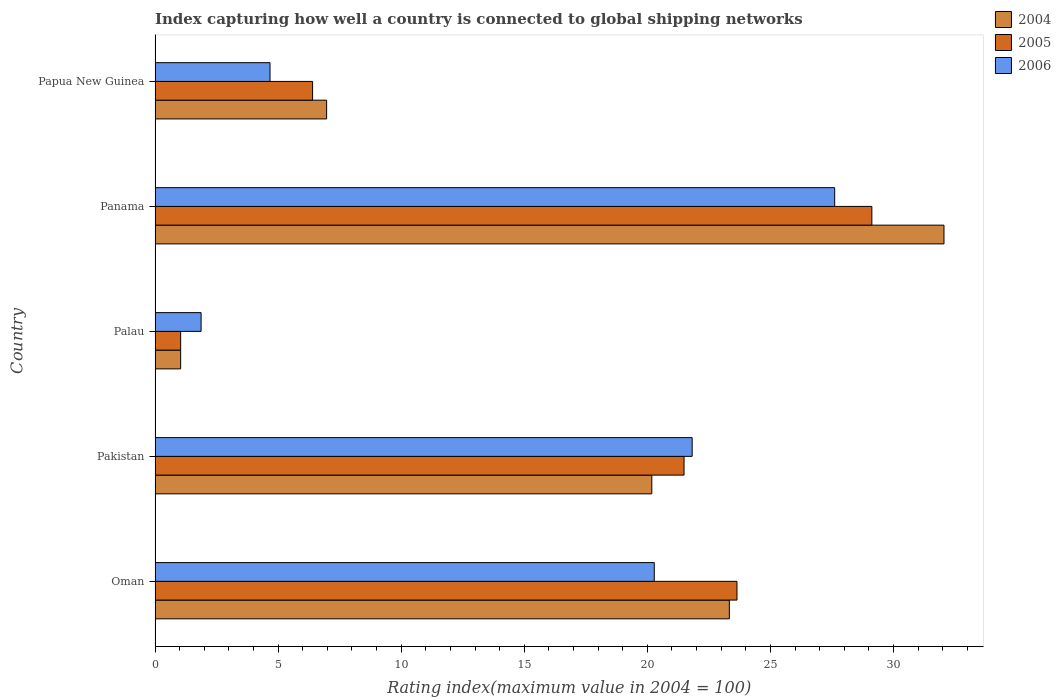Are the number of bars on each tick of the Y-axis equal?
Provide a succinct answer. Yes. How many bars are there on the 2nd tick from the top?
Ensure brevity in your answer.  3. What is the label of the 1st group of bars from the top?
Your answer should be very brief. Papua New Guinea. What is the rating index in 2006 in Papua New Guinea?
Provide a succinct answer. 4.67. Across all countries, what is the maximum rating index in 2006?
Your answer should be very brief. 27.61. Across all countries, what is the minimum rating index in 2006?
Provide a short and direct response. 1.87. In which country was the rating index in 2006 maximum?
Make the answer very short. Panama. In which country was the rating index in 2005 minimum?
Keep it short and to the point. Palau. What is the total rating index in 2004 in the graph?
Your answer should be very brief. 83.57. What is the difference between the rating index in 2004 in Palau and that in Papua New Guinea?
Your answer should be very brief. -5.93. What is the difference between the rating index in 2004 in Panama and the rating index in 2006 in Palau?
Give a very brief answer. 30.18. What is the average rating index in 2006 per country?
Give a very brief answer. 15.25. What is the difference between the rating index in 2004 and rating index in 2006 in Papua New Guinea?
Your response must be concise. 2.3. What is the ratio of the rating index in 2006 in Palau to that in Papua New Guinea?
Offer a very short reply. 0.4. What is the difference between the highest and the second highest rating index in 2006?
Offer a very short reply. 5.79. What is the difference between the highest and the lowest rating index in 2004?
Keep it short and to the point. 31.01. What does the 2nd bar from the bottom in Papua New Guinea represents?
Your answer should be compact. 2005. Is it the case that in every country, the sum of the rating index in 2004 and rating index in 2005 is greater than the rating index in 2006?
Offer a very short reply. Yes. How many bars are there?
Make the answer very short. 15. What is the difference between two consecutive major ticks on the X-axis?
Provide a succinct answer. 5. Does the graph contain any zero values?
Your response must be concise. No. Where does the legend appear in the graph?
Keep it short and to the point. Top right. What is the title of the graph?
Give a very brief answer. Index capturing how well a country is connected to global shipping networks. What is the label or title of the X-axis?
Provide a short and direct response. Rating index(maximum value in 2004 = 100). What is the Rating index(maximum value in 2004 = 100) of 2004 in Oman?
Your answer should be compact. 23.33. What is the Rating index(maximum value in 2004 = 100) of 2005 in Oman?
Your answer should be very brief. 23.64. What is the Rating index(maximum value in 2004 = 100) in 2006 in Oman?
Provide a succinct answer. 20.28. What is the Rating index(maximum value in 2004 = 100) of 2004 in Pakistan?
Keep it short and to the point. 20.18. What is the Rating index(maximum value in 2004 = 100) in 2005 in Pakistan?
Your answer should be very brief. 21.49. What is the Rating index(maximum value in 2004 = 100) of 2006 in Pakistan?
Offer a very short reply. 21.82. What is the Rating index(maximum value in 2004 = 100) in 2004 in Palau?
Offer a very short reply. 1.04. What is the Rating index(maximum value in 2004 = 100) in 2006 in Palau?
Provide a succinct answer. 1.87. What is the Rating index(maximum value in 2004 = 100) of 2004 in Panama?
Ensure brevity in your answer.  32.05. What is the Rating index(maximum value in 2004 = 100) in 2005 in Panama?
Make the answer very short. 29.12. What is the Rating index(maximum value in 2004 = 100) in 2006 in Panama?
Your answer should be very brief. 27.61. What is the Rating index(maximum value in 2004 = 100) in 2004 in Papua New Guinea?
Your answer should be compact. 6.97. What is the Rating index(maximum value in 2004 = 100) in 2005 in Papua New Guinea?
Your response must be concise. 6.4. What is the Rating index(maximum value in 2004 = 100) of 2006 in Papua New Guinea?
Your answer should be compact. 4.67. Across all countries, what is the maximum Rating index(maximum value in 2004 = 100) in 2004?
Provide a succinct answer. 32.05. Across all countries, what is the maximum Rating index(maximum value in 2004 = 100) of 2005?
Make the answer very short. 29.12. Across all countries, what is the maximum Rating index(maximum value in 2004 = 100) of 2006?
Make the answer very short. 27.61. Across all countries, what is the minimum Rating index(maximum value in 2004 = 100) in 2005?
Give a very brief answer. 1.04. Across all countries, what is the minimum Rating index(maximum value in 2004 = 100) of 2006?
Your answer should be compact. 1.87. What is the total Rating index(maximum value in 2004 = 100) of 2004 in the graph?
Your answer should be compact. 83.57. What is the total Rating index(maximum value in 2004 = 100) of 2005 in the graph?
Keep it short and to the point. 81.69. What is the total Rating index(maximum value in 2004 = 100) in 2006 in the graph?
Your response must be concise. 76.25. What is the difference between the Rating index(maximum value in 2004 = 100) in 2004 in Oman and that in Pakistan?
Keep it short and to the point. 3.15. What is the difference between the Rating index(maximum value in 2004 = 100) of 2005 in Oman and that in Pakistan?
Offer a terse response. 2.15. What is the difference between the Rating index(maximum value in 2004 = 100) in 2006 in Oman and that in Pakistan?
Ensure brevity in your answer.  -1.54. What is the difference between the Rating index(maximum value in 2004 = 100) in 2004 in Oman and that in Palau?
Your response must be concise. 22.29. What is the difference between the Rating index(maximum value in 2004 = 100) in 2005 in Oman and that in Palau?
Ensure brevity in your answer.  22.6. What is the difference between the Rating index(maximum value in 2004 = 100) of 2006 in Oman and that in Palau?
Your answer should be very brief. 18.41. What is the difference between the Rating index(maximum value in 2004 = 100) of 2004 in Oman and that in Panama?
Keep it short and to the point. -8.72. What is the difference between the Rating index(maximum value in 2004 = 100) of 2005 in Oman and that in Panama?
Provide a succinct answer. -5.48. What is the difference between the Rating index(maximum value in 2004 = 100) in 2006 in Oman and that in Panama?
Give a very brief answer. -7.33. What is the difference between the Rating index(maximum value in 2004 = 100) in 2004 in Oman and that in Papua New Guinea?
Ensure brevity in your answer.  16.36. What is the difference between the Rating index(maximum value in 2004 = 100) of 2005 in Oman and that in Papua New Guinea?
Ensure brevity in your answer.  17.24. What is the difference between the Rating index(maximum value in 2004 = 100) of 2006 in Oman and that in Papua New Guinea?
Offer a very short reply. 15.61. What is the difference between the Rating index(maximum value in 2004 = 100) of 2004 in Pakistan and that in Palau?
Make the answer very short. 19.14. What is the difference between the Rating index(maximum value in 2004 = 100) of 2005 in Pakistan and that in Palau?
Offer a terse response. 20.45. What is the difference between the Rating index(maximum value in 2004 = 100) in 2006 in Pakistan and that in Palau?
Give a very brief answer. 19.95. What is the difference between the Rating index(maximum value in 2004 = 100) of 2004 in Pakistan and that in Panama?
Provide a succinct answer. -11.87. What is the difference between the Rating index(maximum value in 2004 = 100) of 2005 in Pakistan and that in Panama?
Give a very brief answer. -7.63. What is the difference between the Rating index(maximum value in 2004 = 100) of 2006 in Pakistan and that in Panama?
Provide a short and direct response. -5.79. What is the difference between the Rating index(maximum value in 2004 = 100) in 2004 in Pakistan and that in Papua New Guinea?
Your response must be concise. 13.21. What is the difference between the Rating index(maximum value in 2004 = 100) of 2005 in Pakistan and that in Papua New Guinea?
Your response must be concise. 15.09. What is the difference between the Rating index(maximum value in 2004 = 100) of 2006 in Pakistan and that in Papua New Guinea?
Provide a succinct answer. 17.15. What is the difference between the Rating index(maximum value in 2004 = 100) in 2004 in Palau and that in Panama?
Make the answer very short. -31.01. What is the difference between the Rating index(maximum value in 2004 = 100) of 2005 in Palau and that in Panama?
Offer a very short reply. -28.08. What is the difference between the Rating index(maximum value in 2004 = 100) of 2006 in Palau and that in Panama?
Keep it short and to the point. -25.74. What is the difference between the Rating index(maximum value in 2004 = 100) of 2004 in Palau and that in Papua New Guinea?
Offer a very short reply. -5.93. What is the difference between the Rating index(maximum value in 2004 = 100) in 2005 in Palau and that in Papua New Guinea?
Give a very brief answer. -5.36. What is the difference between the Rating index(maximum value in 2004 = 100) in 2004 in Panama and that in Papua New Guinea?
Your answer should be compact. 25.08. What is the difference between the Rating index(maximum value in 2004 = 100) in 2005 in Panama and that in Papua New Guinea?
Offer a terse response. 22.72. What is the difference between the Rating index(maximum value in 2004 = 100) of 2006 in Panama and that in Papua New Guinea?
Provide a short and direct response. 22.94. What is the difference between the Rating index(maximum value in 2004 = 100) in 2004 in Oman and the Rating index(maximum value in 2004 = 100) in 2005 in Pakistan?
Make the answer very short. 1.84. What is the difference between the Rating index(maximum value in 2004 = 100) of 2004 in Oman and the Rating index(maximum value in 2004 = 100) of 2006 in Pakistan?
Offer a very short reply. 1.51. What is the difference between the Rating index(maximum value in 2004 = 100) in 2005 in Oman and the Rating index(maximum value in 2004 = 100) in 2006 in Pakistan?
Keep it short and to the point. 1.82. What is the difference between the Rating index(maximum value in 2004 = 100) of 2004 in Oman and the Rating index(maximum value in 2004 = 100) of 2005 in Palau?
Keep it short and to the point. 22.29. What is the difference between the Rating index(maximum value in 2004 = 100) of 2004 in Oman and the Rating index(maximum value in 2004 = 100) of 2006 in Palau?
Offer a very short reply. 21.46. What is the difference between the Rating index(maximum value in 2004 = 100) of 2005 in Oman and the Rating index(maximum value in 2004 = 100) of 2006 in Palau?
Keep it short and to the point. 21.77. What is the difference between the Rating index(maximum value in 2004 = 100) in 2004 in Oman and the Rating index(maximum value in 2004 = 100) in 2005 in Panama?
Your answer should be compact. -5.79. What is the difference between the Rating index(maximum value in 2004 = 100) of 2004 in Oman and the Rating index(maximum value in 2004 = 100) of 2006 in Panama?
Offer a terse response. -4.28. What is the difference between the Rating index(maximum value in 2004 = 100) in 2005 in Oman and the Rating index(maximum value in 2004 = 100) in 2006 in Panama?
Provide a short and direct response. -3.97. What is the difference between the Rating index(maximum value in 2004 = 100) of 2004 in Oman and the Rating index(maximum value in 2004 = 100) of 2005 in Papua New Guinea?
Ensure brevity in your answer.  16.93. What is the difference between the Rating index(maximum value in 2004 = 100) of 2004 in Oman and the Rating index(maximum value in 2004 = 100) of 2006 in Papua New Guinea?
Provide a short and direct response. 18.66. What is the difference between the Rating index(maximum value in 2004 = 100) of 2005 in Oman and the Rating index(maximum value in 2004 = 100) of 2006 in Papua New Guinea?
Give a very brief answer. 18.97. What is the difference between the Rating index(maximum value in 2004 = 100) in 2004 in Pakistan and the Rating index(maximum value in 2004 = 100) in 2005 in Palau?
Provide a short and direct response. 19.14. What is the difference between the Rating index(maximum value in 2004 = 100) in 2004 in Pakistan and the Rating index(maximum value in 2004 = 100) in 2006 in Palau?
Give a very brief answer. 18.31. What is the difference between the Rating index(maximum value in 2004 = 100) in 2005 in Pakistan and the Rating index(maximum value in 2004 = 100) in 2006 in Palau?
Your answer should be compact. 19.62. What is the difference between the Rating index(maximum value in 2004 = 100) in 2004 in Pakistan and the Rating index(maximum value in 2004 = 100) in 2005 in Panama?
Make the answer very short. -8.94. What is the difference between the Rating index(maximum value in 2004 = 100) in 2004 in Pakistan and the Rating index(maximum value in 2004 = 100) in 2006 in Panama?
Provide a short and direct response. -7.43. What is the difference between the Rating index(maximum value in 2004 = 100) in 2005 in Pakistan and the Rating index(maximum value in 2004 = 100) in 2006 in Panama?
Make the answer very short. -6.12. What is the difference between the Rating index(maximum value in 2004 = 100) of 2004 in Pakistan and the Rating index(maximum value in 2004 = 100) of 2005 in Papua New Guinea?
Offer a terse response. 13.78. What is the difference between the Rating index(maximum value in 2004 = 100) in 2004 in Pakistan and the Rating index(maximum value in 2004 = 100) in 2006 in Papua New Guinea?
Provide a succinct answer. 15.51. What is the difference between the Rating index(maximum value in 2004 = 100) in 2005 in Pakistan and the Rating index(maximum value in 2004 = 100) in 2006 in Papua New Guinea?
Your answer should be very brief. 16.82. What is the difference between the Rating index(maximum value in 2004 = 100) in 2004 in Palau and the Rating index(maximum value in 2004 = 100) in 2005 in Panama?
Keep it short and to the point. -28.08. What is the difference between the Rating index(maximum value in 2004 = 100) in 2004 in Palau and the Rating index(maximum value in 2004 = 100) in 2006 in Panama?
Your answer should be compact. -26.57. What is the difference between the Rating index(maximum value in 2004 = 100) of 2005 in Palau and the Rating index(maximum value in 2004 = 100) of 2006 in Panama?
Keep it short and to the point. -26.57. What is the difference between the Rating index(maximum value in 2004 = 100) of 2004 in Palau and the Rating index(maximum value in 2004 = 100) of 2005 in Papua New Guinea?
Your answer should be compact. -5.36. What is the difference between the Rating index(maximum value in 2004 = 100) of 2004 in Palau and the Rating index(maximum value in 2004 = 100) of 2006 in Papua New Guinea?
Ensure brevity in your answer.  -3.63. What is the difference between the Rating index(maximum value in 2004 = 100) in 2005 in Palau and the Rating index(maximum value in 2004 = 100) in 2006 in Papua New Guinea?
Your answer should be compact. -3.63. What is the difference between the Rating index(maximum value in 2004 = 100) in 2004 in Panama and the Rating index(maximum value in 2004 = 100) in 2005 in Papua New Guinea?
Your answer should be very brief. 25.65. What is the difference between the Rating index(maximum value in 2004 = 100) in 2004 in Panama and the Rating index(maximum value in 2004 = 100) in 2006 in Papua New Guinea?
Offer a terse response. 27.38. What is the difference between the Rating index(maximum value in 2004 = 100) in 2005 in Panama and the Rating index(maximum value in 2004 = 100) in 2006 in Papua New Guinea?
Ensure brevity in your answer.  24.45. What is the average Rating index(maximum value in 2004 = 100) in 2004 per country?
Keep it short and to the point. 16.71. What is the average Rating index(maximum value in 2004 = 100) in 2005 per country?
Offer a very short reply. 16.34. What is the average Rating index(maximum value in 2004 = 100) in 2006 per country?
Make the answer very short. 15.25. What is the difference between the Rating index(maximum value in 2004 = 100) of 2004 and Rating index(maximum value in 2004 = 100) of 2005 in Oman?
Offer a terse response. -0.31. What is the difference between the Rating index(maximum value in 2004 = 100) of 2004 and Rating index(maximum value in 2004 = 100) of 2006 in Oman?
Your answer should be very brief. 3.05. What is the difference between the Rating index(maximum value in 2004 = 100) of 2005 and Rating index(maximum value in 2004 = 100) of 2006 in Oman?
Provide a short and direct response. 3.36. What is the difference between the Rating index(maximum value in 2004 = 100) of 2004 and Rating index(maximum value in 2004 = 100) of 2005 in Pakistan?
Offer a terse response. -1.31. What is the difference between the Rating index(maximum value in 2004 = 100) of 2004 and Rating index(maximum value in 2004 = 100) of 2006 in Pakistan?
Your answer should be very brief. -1.64. What is the difference between the Rating index(maximum value in 2004 = 100) in 2005 and Rating index(maximum value in 2004 = 100) in 2006 in Pakistan?
Your answer should be very brief. -0.33. What is the difference between the Rating index(maximum value in 2004 = 100) of 2004 and Rating index(maximum value in 2004 = 100) of 2006 in Palau?
Offer a terse response. -0.83. What is the difference between the Rating index(maximum value in 2004 = 100) in 2005 and Rating index(maximum value in 2004 = 100) in 2006 in Palau?
Provide a short and direct response. -0.83. What is the difference between the Rating index(maximum value in 2004 = 100) in 2004 and Rating index(maximum value in 2004 = 100) in 2005 in Panama?
Your answer should be compact. 2.93. What is the difference between the Rating index(maximum value in 2004 = 100) in 2004 and Rating index(maximum value in 2004 = 100) in 2006 in Panama?
Your answer should be compact. 4.44. What is the difference between the Rating index(maximum value in 2004 = 100) in 2005 and Rating index(maximum value in 2004 = 100) in 2006 in Panama?
Your answer should be compact. 1.51. What is the difference between the Rating index(maximum value in 2004 = 100) of 2004 and Rating index(maximum value in 2004 = 100) of 2005 in Papua New Guinea?
Give a very brief answer. 0.57. What is the difference between the Rating index(maximum value in 2004 = 100) in 2004 and Rating index(maximum value in 2004 = 100) in 2006 in Papua New Guinea?
Provide a short and direct response. 2.3. What is the difference between the Rating index(maximum value in 2004 = 100) of 2005 and Rating index(maximum value in 2004 = 100) of 2006 in Papua New Guinea?
Ensure brevity in your answer.  1.73. What is the ratio of the Rating index(maximum value in 2004 = 100) of 2004 in Oman to that in Pakistan?
Make the answer very short. 1.16. What is the ratio of the Rating index(maximum value in 2004 = 100) of 2005 in Oman to that in Pakistan?
Offer a very short reply. 1.1. What is the ratio of the Rating index(maximum value in 2004 = 100) in 2006 in Oman to that in Pakistan?
Offer a terse response. 0.93. What is the ratio of the Rating index(maximum value in 2004 = 100) of 2004 in Oman to that in Palau?
Ensure brevity in your answer.  22.43. What is the ratio of the Rating index(maximum value in 2004 = 100) in 2005 in Oman to that in Palau?
Your answer should be very brief. 22.73. What is the ratio of the Rating index(maximum value in 2004 = 100) in 2006 in Oman to that in Palau?
Offer a terse response. 10.84. What is the ratio of the Rating index(maximum value in 2004 = 100) of 2004 in Oman to that in Panama?
Offer a terse response. 0.73. What is the ratio of the Rating index(maximum value in 2004 = 100) in 2005 in Oman to that in Panama?
Your answer should be compact. 0.81. What is the ratio of the Rating index(maximum value in 2004 = 100) of 2006 in Oman to that in Panama?
Offer a very short reply. 0.73. What is the ratio of the Rating index(maximum value in 2004 = 100) in 2004 in Oman to that in Papua New Guinea?
Ensure brevity in your answer.  3.35. What is the ratio of the Rating index(maximum value in 2004 = 100) in 2005 in Oman to that in Papua New Guinea?
Make the answer very short. 3.69. What is the ratio of the Rating index(maximum value in 2004 = 100) of 2006 in Oman to that in Papua New Guinea?
Provide a short and direct response. 4.34. What is the ratio of the Rating index(maximum value in 2004 = 100) in 2004 in Pakistan to that in Palau?
Your response must be concise. 19.4. What is the ratio of the Rating index(maximum value in 2004 = 100) in 2005 in Pakistan to that in Palau?
Offer a terse response. 20.66. What is the ratio of the Rating index(maximum value in 2004 = 100) in 2006 in Pakistan to that in Palau?
Provide a short and direct response. 11.67. What is the ratio of the Rating index(maximum value in 2004 = 100) of 2004 in Pakistan to that in Panama?
Ensure brevity in your answer.  0.63. What is the ratio of the Rating index(maximum value in 2004 = 100) of 2005 in Pakistan to that in Panama?
Give a very brief answer. 0.74. What is the ratio of the Rating index(maximum value in 2004 = 100) in 2006 in Pakistan to that in Panama?
Keep it short and to the point. 0.79. What is the ratio of the Rating index(maximum value in 2004 = 100) in 2004 in Pakistan to that in Papua New Guinea?
Your answer should be very brief. 2.9. What is the ratio of the Rating index(maximum value in 2004 = 100) of 2005 in Pakistan to that in Papua New Guinea?
Your response must be concise. 3.36. What is the ratio of the Rating index(maximum value in 2004 = 100) of 2006 in Pakistan to that in Papua New Guinea?
Ensure brevity in your answer.  4.67. What is the ratio of the Rating index(maximum value in 2004 = 100) of 2004 in Palau to that in Panama?
Your answer should be very brief. 0.03. What is the ratio of the Rating index(maximum value in 2004 = 100) of 2005 in Palau to that in Panama?
Your answer should be very brief. 0.04. What is the ratio of the Rating index(maximum value in 2004 = 100) of 2006 in Palau to that in Panama?
Make the answer very short. 0.07. What is the ratio of the Rating index(maximum value in 2004 = 100) in 2004 in Palau to that in Papua New Guinea?
Offer a terse response. 0.15. What is the ratio of the Rating index(maximum value in 2004 = 100) in 2005 in Palau to that in Papua New Guinea?
Your response must be concise. 0.16. What is the ratio of the Rating index(maximum value in 2004 = 100) of 2006 in Palau to that in Papua New Guinea?
Provide a short and direct response. 0.4. What is the ratio of the Rating index(maximum value in 2004 = 100) of 2004 in Panama to that in Papua New Guinea?
Offer a very short reply. 4.6. What is the ratio of the Rating index(maximum value in 2004 = 100) of 2005 in Panama to that in Papua New Guinea?
Your answer should be compact. 4.55. What is the ratio of the Rating index(maximum value in 2004 = 100) in 2006 in Panama to that in Papua New Guinea?
Your answer should be very brief. 5.91. What is the difference between the highest and the second highest Rating index(maximum value in 2004 = 100) of 2004?
Provide a short and direct response. 8.72. What is the difference between the highest and the second highest Rating index(maximum value in 2004 = 100) of 2005?
Your response must be concise. 5.48. What is the difference between the highest and the second highest Rating index(maximum value in 2004 = 100) in 2006?
Offer a terse response. 5.79. What is the difference between the highest and the lowest Rating index(maximum value in 2004 = 100) in 2004?
Offer a terse response. 31.01. What is the difference between the highest and the lowest Rating index(maximum value in 2004 = 100) of 2005?
Keep it short and to the point. 28.08. What is the difference between the highest and the lowest Rating index(maximum value in 2004 = 100) in 2006?
Offer a terse response. 25.74. 